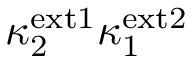<formula> <loc_0><loc_0><loc_500><loc_500>\kappa _ { 2 } ^ { e x t 1 } \kappa _ { 1 } ^ { e x t 2 }</formula> 